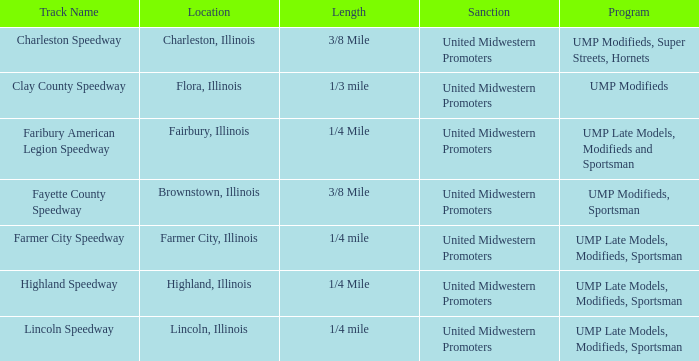What site is farmer city speedway? Farmer City, Illinois. 